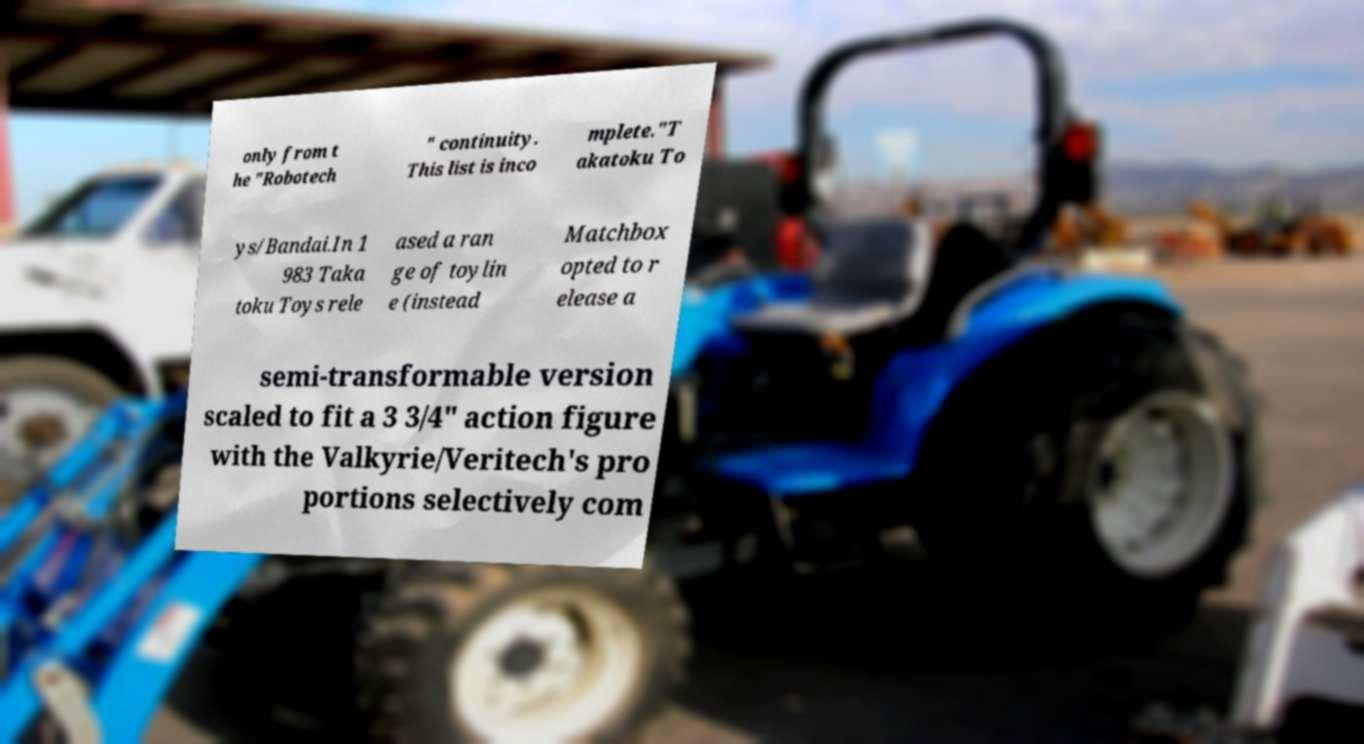I need the written content from this picture converted into text. Can you do that? only from t he "Robotech " continuity. This list is inco mplete."T akatoku To ys/Bandai.In 1 983 Taka toku Toys rele ased a ran ge of toylin e (instead Matchbox opted to r elease a semi-transformable version scaled to fit a 3 3/4" action figure with the Valkyrie/Veritech's pro portions selectively com 